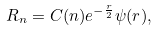<formula> <loc_0><loc_0><loc_500><loc_500>R _ { n } = C ( n ) e ^ { - \frac { r } { 2 } } \psi ( r ) ,</formula> 